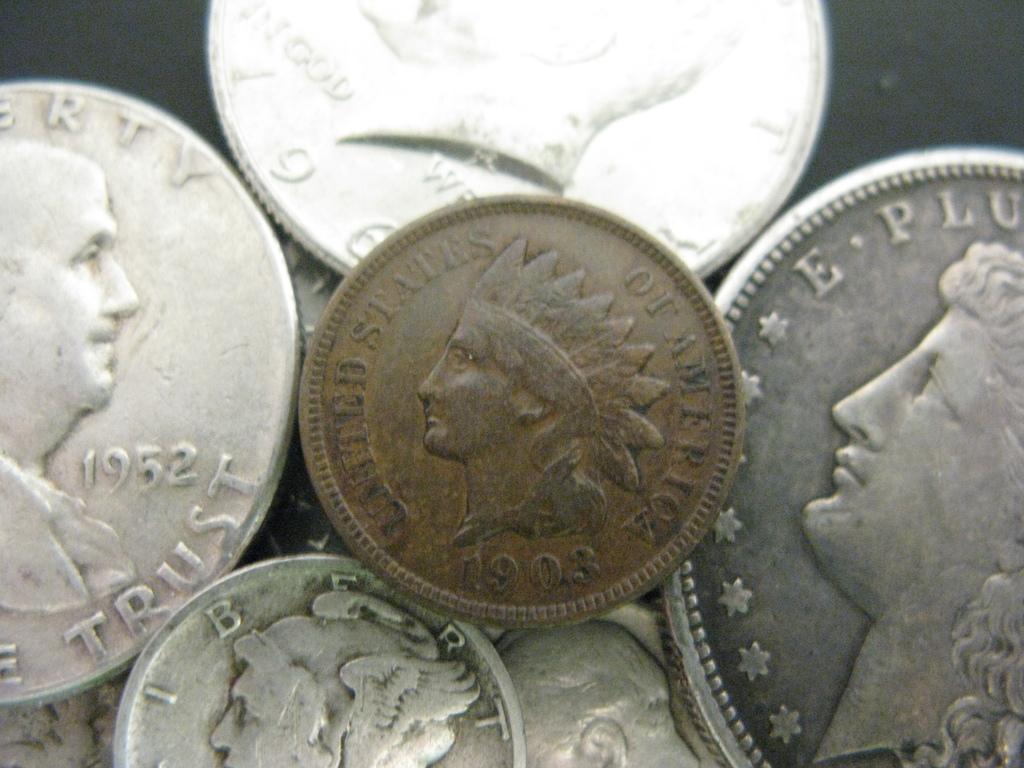What year is on the left coin?
Offer a terse response. 1952. What year is on the coin in the middle?
Give a very brief answer. 1903. 